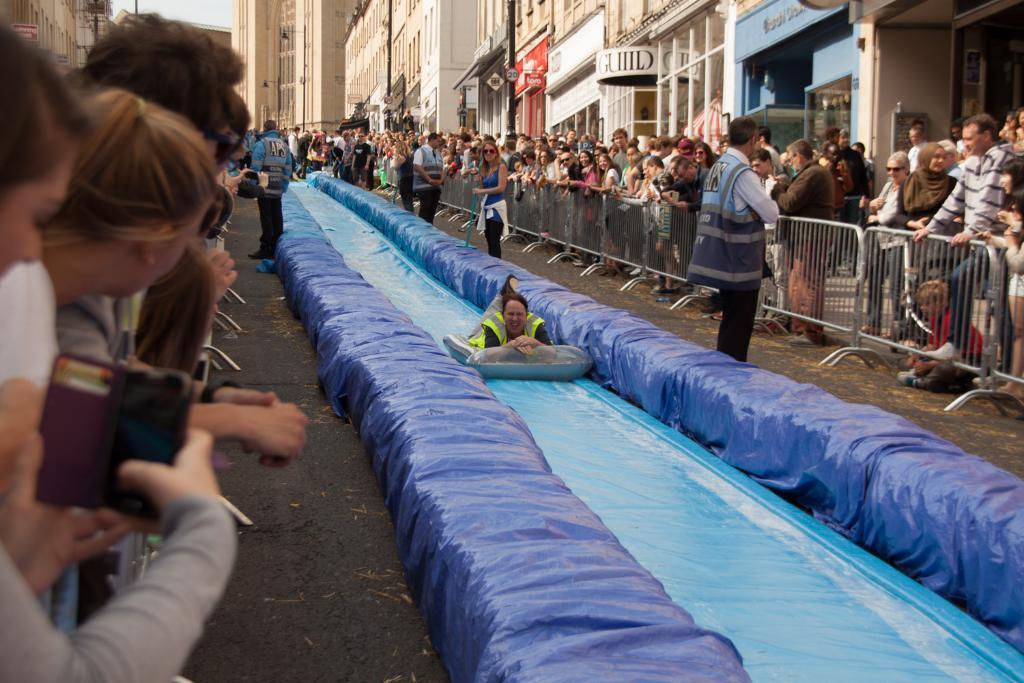What is happening with the group of people in the image? There is a group of people standing in the image. What is the woman doing in the image? A woman is sliding on an object in the image. What can be seen in the background of the image? There is a fence, poles, and buildings in the background of the image. How does the woman swim in the image? The woman is not swimming in the image; she is sliding on an object. What type of recess is visible in the image? There is no recess present in the image. 